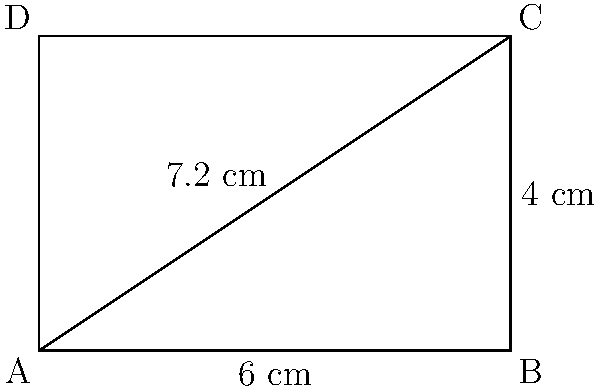As a struggling writer, you're designing the cover for your self-published book. The diagonal of the rectangular cover measures 7.2 cm. If the width of the cover is 6 cm, what is the height of the cover? Round your answer to the nearest tenth of a centimeter. Let's approach this step-by-step:

1) In a rectangle, the diagonal forms the hypotenuse of a right triangle. We can use the Pythagorean theorem to solve this problem.

2) Let's denote:
   - width of the cover = $w$ = 6 cm
   - height of the cover = $h$ (unknown)
   - diagonal of the cover = $d$ = 7.2 cm

3) According to the Pythagorean theorem:
   $w^2 + h^2 = d^2$

4) Substituting the known values:
   $6^2 + h^2 = 7.2^2$

5) Simplify:
   $36 + h^2 = 51.84$

6) Subtract 36 from both sides:
   $h^2 = 51.84 - 36 = 15.84$

7) Take the square root of both sides:
   $h = \sqrt{15.84} \approx 3.98$

8) Rounding to the nearest tenth:
   $h \approx 4.0$ cm
Answer: 4.0 cm 